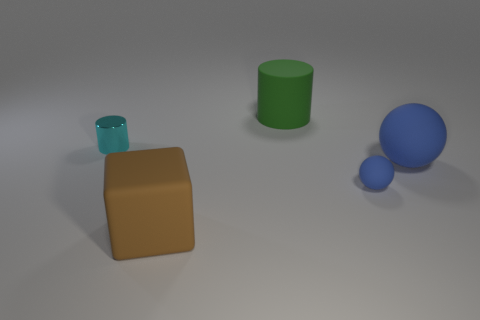Subtract all blue spheres. How many were subtracted if there are1blue spheres left? 1 Subtract all balls. How many objects are left? 3 Subtract 2 cylinders. How many cylinders are left? 0 Subtract all yellow spheres. Subtract all green cylinders. How many spheres are left? 2 Subtract all green blocks. How many blue cylinders are left? 0 Subtract all green matte objects. Subtract all blue balls. How many objects are left? 2 Add 3 big blue matte spheres. How many big blue matte spheres are left? 4 Add 1 yellow metal things. How many yellow metal things exist? 1 Add 2 large spheres. How many objects exist? 7 Subtract all cyan cylinders. How many cylinders are left? 1 